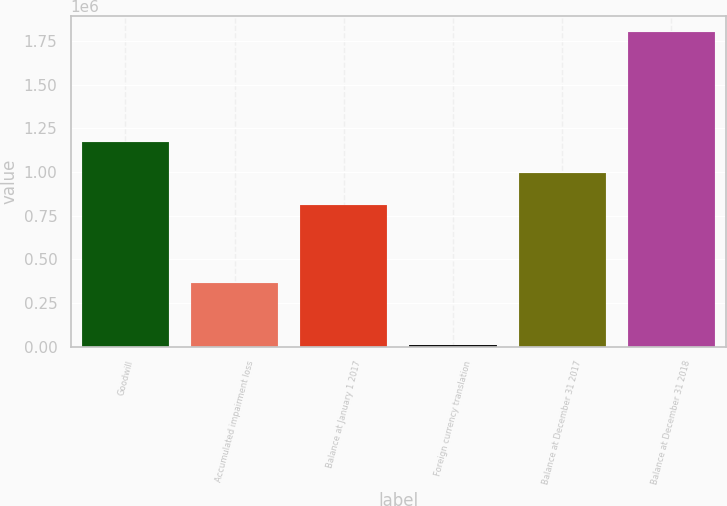Convert chart. <chart><loc_0><loc_0><loc_500><loc_500><bar_chart><fcel>Goodwill<fcel>Accumulated impairment loss<fcel>Balance at January 1 2017<fcel>Foreign currency translation<fcel>Balance at December 31 2017<fcel>Balance at December 31 2018<nl><fcel>1.17469e+06<fcel>362348<fcel>812344<fcel>8717<fcel>991583<fcel>1.8011e+06<nl></chart> 